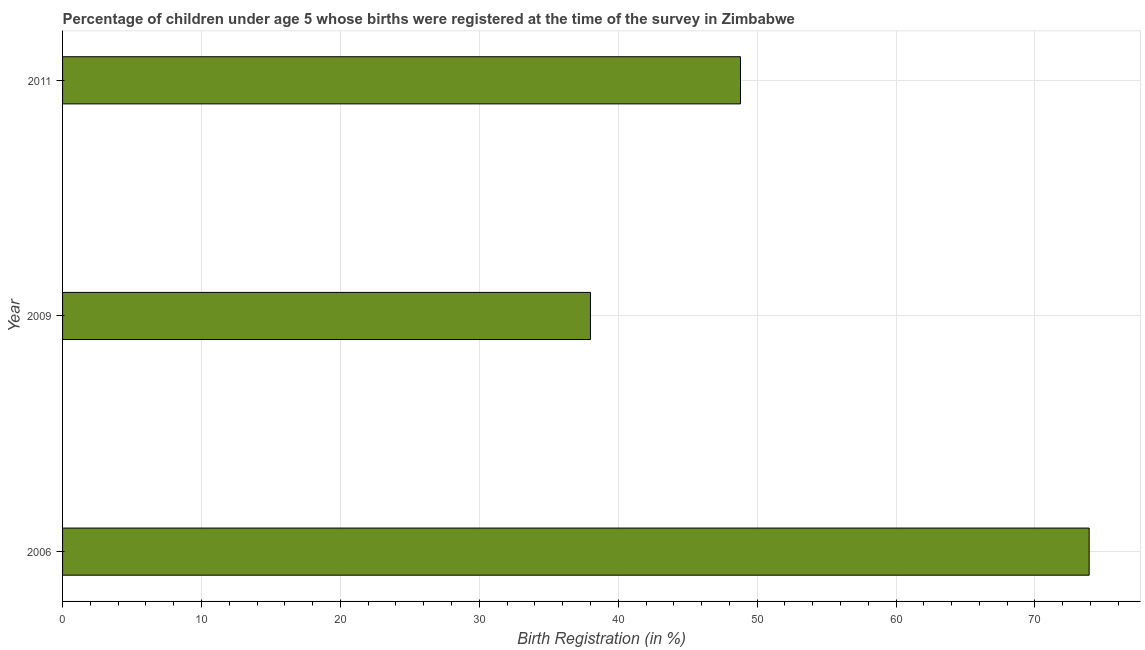What is the title of the graph?
Your response must be concise. Percentage of children under age 5 whose births were registered at the time of the survey in Zimbabwe. What is the label or title of the X-axis?
Offer a very short reply. Birth Registration (in %). What is the label or title of the Y-axis?
Provide a short and direct response. Year. What is the birth registration in 2011?
Offer a very short reply. 48.8. Across all years, what is the maximum birth registration?
Your answer should be very brief. 73.9. Across all years, what is the minimum birth registration?
Give a very brief answer. 38. In which year was the birth registration minimum?
Your answer should be compact. 2009. What is the sum of the birth registration?
Your answer should be very brief. 160.7. What is the difference between the birth registration in 2006 and 2009?
Provide a short and direct response. 35.9. What is the average birth registration per year?
Your answer should be compact. 53.57. What is the median birth registration?
Ensure brevity in your answer.  48.8. Do a majority of the years between 2009 and 2006 (inclusive) have birth registration greater than 60 %?
Give a very brief answer. No. What is the ratio of the birth registration in 2006 to that in 2009?
Keep it short and to the point. 1.95. Is the difference between the birth registration in 2006 and 2009 greater than the difference between any two years?
Provide a short and direct response. Yes. What is the difference between the highest and the second highest birth registration?
Provide a short and direct response. 25.1. Is the sum of the birth registration in 2006 and 2011 greater than the maximum birth registration across all years?
Provide a short and direct response. Yes. What is the difference between the highest and the lowest birth registration?
Your answer should be compact. 35.9. In how many years, is the birth registration greater than the average birth registration taken over all years?
Offer a terse response. 1. Are all the bars in the graph horizontal?
Offer a very short reply. Yes. How many years are there in the graph?
Your answer should be compact. 3. What is the difference between two consecutive major ticks on the X-axis?
Your answer should be compact. 10. Are the values on the major ticks of X-axis written in scientific E-notation?
Offer a very short reply. No. What is the Birth Registration (in %) of 2006?
Offer a very short reply. 73.9. What is the Birth Registration (in %) in 2011?
Offer a very short reply. 48.8. What is the difference between the Birth Registration (in %) in 2006 and 2009?
Keep it short and to the point. 35.9. What is the difference between the Birth Registration (in %) in 2006 and 2011?
Your answer should be compact. 25.1. What is the ratio of the Birth Registration (in %) in 2006 to that in 2009?
Ensure brevity in your answer.  1.95. What is the ratio of the Birth Registration (in %) in 2006 to that in 2011?
Ensure brevity in your answer.  1.51. What is the ratio of the Birth Registration (in %) in 2009 to that in 2011?
Your response must be concise. 0.78. 